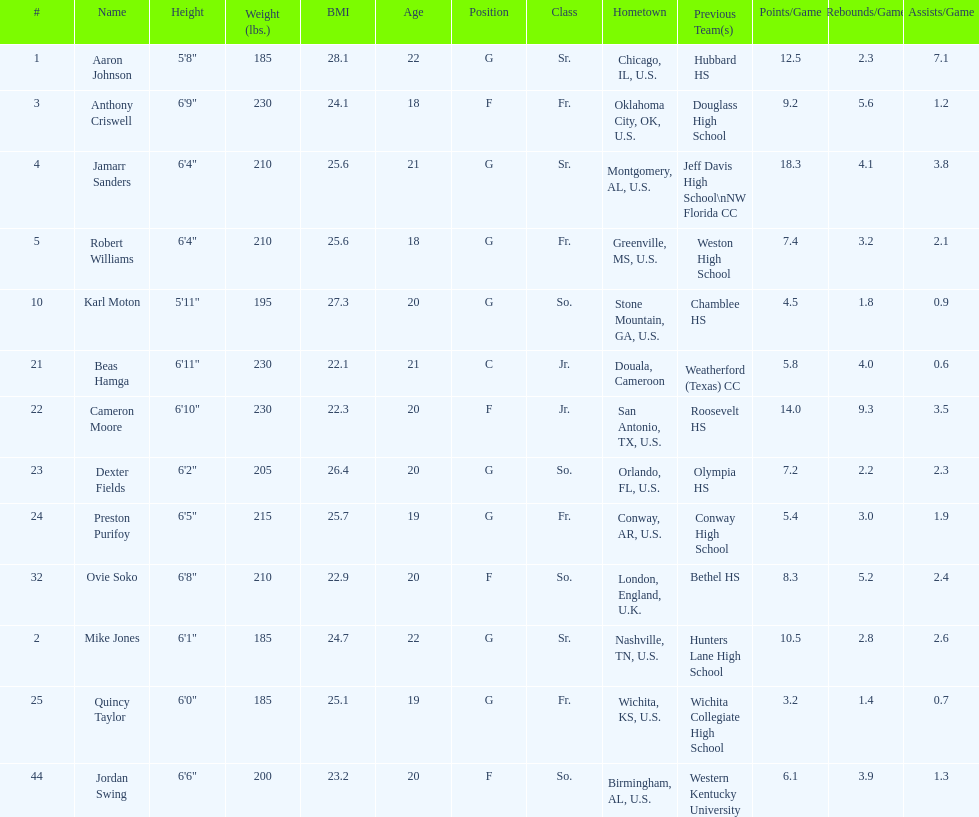What is the difference in weight between dexter fields and quincy taylor? 20. 